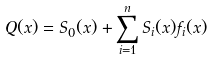Convert formula to latex. <formula><loc_0><loc_0><loc_500><loc_500>Q ( x ) & = S _ { 0 } ( x ) + \sum _ { i = 1 } ^ { n } S _ { i } ( x ) f _ { i } ( x )</formula> 